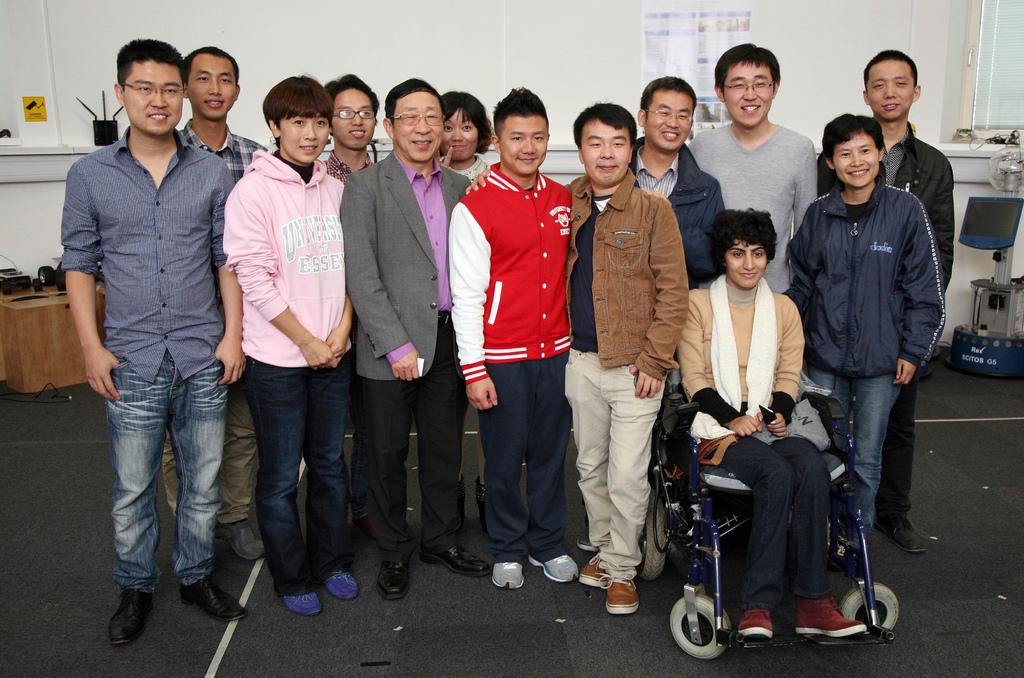What is the primary activity of the people in the image? The people in the image are standing. Can you describe the woman in the image? The woman is sitting on a wheelchair in the image. What type of drink is the woman holding in the image? There is no drink visible in the image, as the woman is sitting on a wheelchair and the focus is on her position rather than any objects she may be holding. 